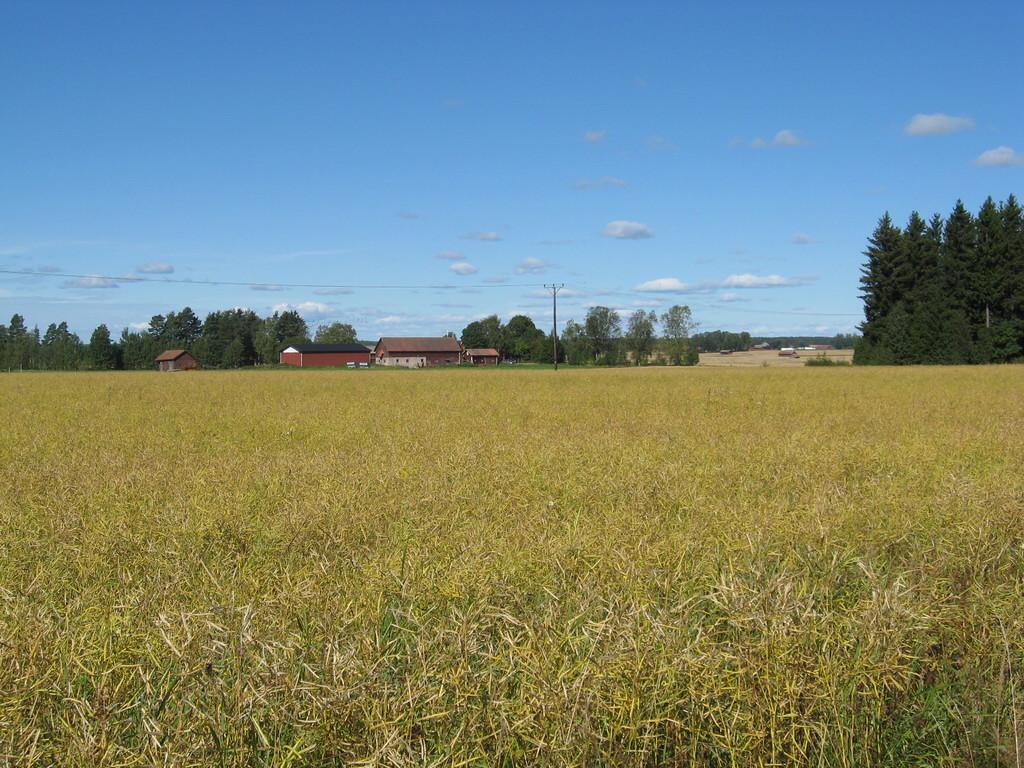What can be seen in the foreground of the image? There is greenery in the foreground of the image. What is visible in the background of the image? There are houses, trees, a pole, and the sky visible in the background of the image. Can you describe the sky in the image? The sky is visible in the background of the image, and there is a cloud present. How many children are playing with the mark in the image? There are no children or marks present in the image. What type of cellar can be seen in the image? There is no cellar present in the image. 